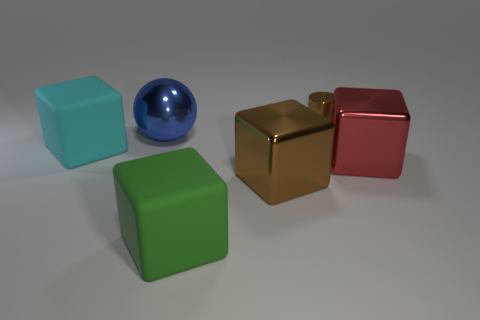Add 1 big brown blocks. How many objects exist? 7 Subtract all brown metallic blocks. How many blocks are left? 3 Subtract all cubes. How many objects are left? 2 Subtract all green balls. Subtract all purple cylinders. How many balls are left? 1 Subtract all gray balls. How many brown blocks are left? 1 Subtract all tiny gray matte blocks. Subtract all shiny things. How many objects are left? 2 Add 3 green things. How many green things are left? 4 Add 5 big purple rubber balls. How many big purple rubber balls exist? 5 Subtract all brown blocks. How many blocks are left? 3 Subtract 0 red spheres. How many objects are left? 6 